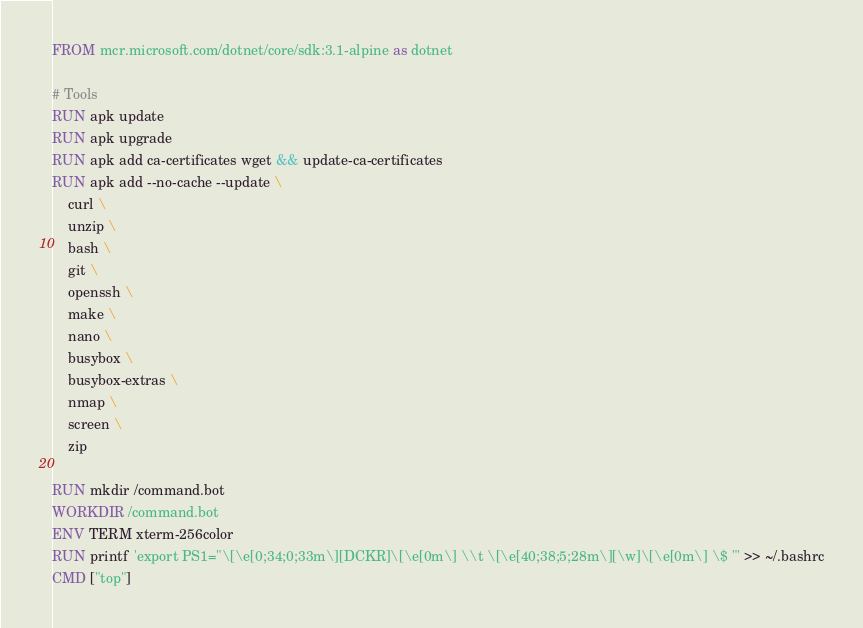<code> <loc_0><loc_0><loc_500><loc_500><_Dockerfile_>FROM mcr.microsoft.com/dotnet/core/sdk:3.1-alpine as dotnet

# Tools
RUN apk update
RUN apk upgrade
RUN apk add ca-certificates wget && update-ca-certificates
RUN apk add --no-cache --update \
    curl \
    unzip \
    bash \
    git \
    openssh \
    make \
    nano \
    busybox \
    busybox-extras \
    nmap \
    screen \
    zip

RUN mkdir /command.bot
WORKDIR /command.bot
ENV TERM xterm-256color
RUN printf 'export PS1="\[\e[0;34;0;33m\][DCKR]\[\e[0m\] \\t \[\e[40;38;5;28m\][\w]\[\e[0m\] \$ "' >> ~/.bashrc
CMD ["top"]
</code> 